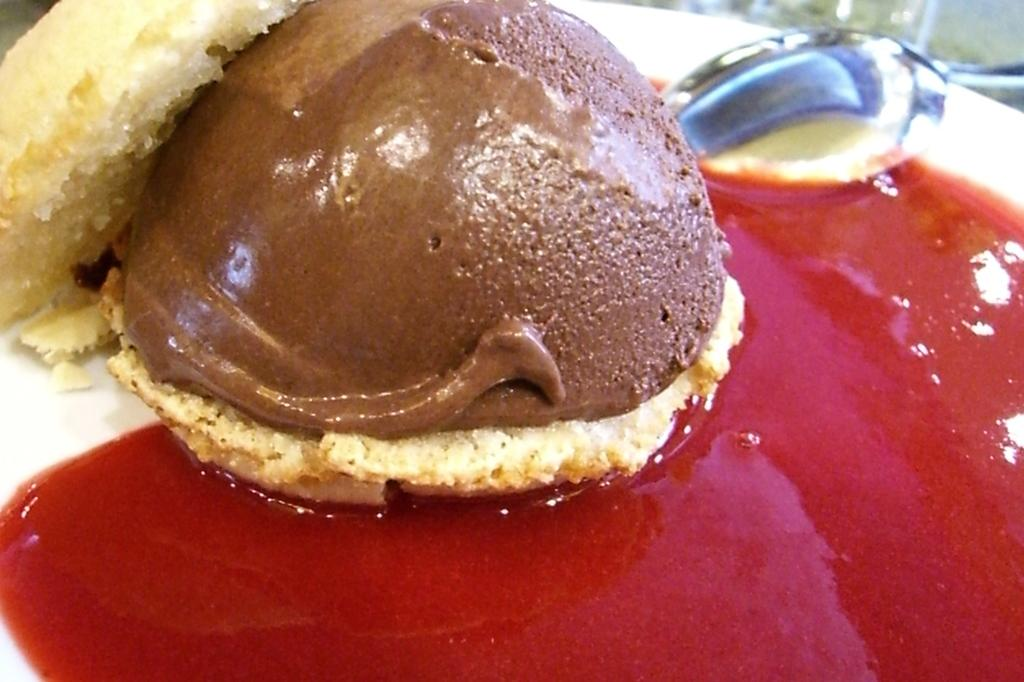What is on the plate in the image? There is food in the plate. What utensil is present in the image? There is a spoon in the image. How many crates are stacked on top of each other in the image? There are no crates present in the image. What type of fruit is visible in the image? There is no fruit visible in the image. 